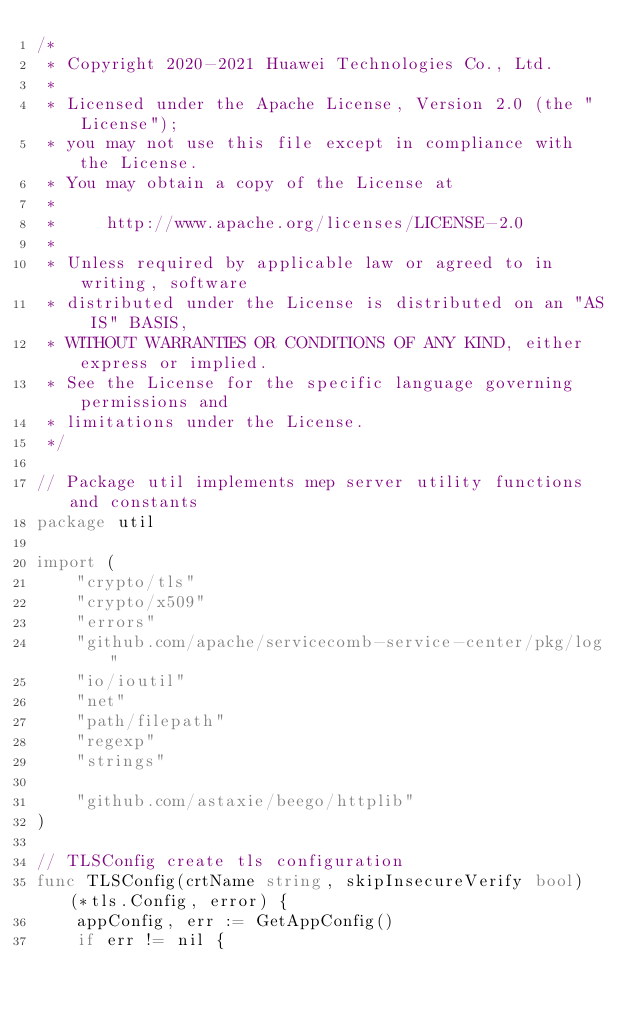<code> <loc_0><loc_0><loc_500><loc_500><_Go_>/*
 * Copyright 2020-2021 Huawei Technologies Co., Ltd.
 *
 * Licensed under the Apache License, Version 2.0 (the "License");
 * you may not use this file except in compliance with the License.
 * You may obtain a copy of the License at
 *
 *     http://www.apache.org/licenses/LICENSE-2.0
 *
 * Unless required by applicable law or agreed to in writing, software
 * distributed under the License is distributed on an "AS IS" BASIS,
 * WITHOUT WARRANTIES OR CONDITIONS OF ANY KIND, either express or implied.
 * See the License for the specific language governing permissions and
 * limitations under the License.
 */

// Package util implements mep server utility functions and constants
package util

import (
	"crypto/tls"
	"crypto/x509"
	"errors"
	"github.com/apache/servicecomb-service-center/pkg/log"
	"io/ioutil"
	"net"
	"path/filepath"
	"regexp"
	"strings"

	"github.com/astaxie/beego/httplib"
)

// TLSConfig create tls configuration
func TLSConfig(crtName string, skipInsecureVerify bool) (*tls.Config, error) {
	appConfig, err := GetAppConfig()
	if err != nil {</code> 